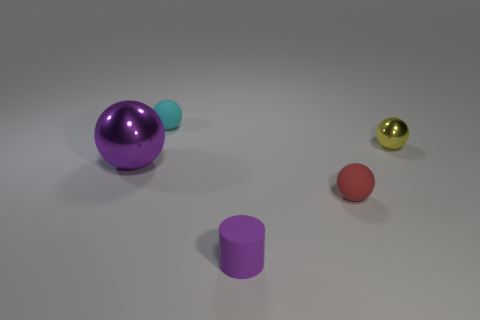Is there anything else that is the same size as the purple metal object?
Keep it short and to the point. No. The red matte object that is the same size as the cyan object is what shape?
Offer a very short reply. Sphere. Is the number of red spheres greater than the number of red metal balls?
Ensure brevity in your answer.  Yes. There is a shiny thing left of the tiny purple rubber thing; is there a matte sphere in front of it?
Provide a succinct answer. Yes. What is the color of the big object that is the same shape as the small yellow object?
Provide a short and direct response. Purple. Is there anything else that has the same shape as the tiny purple rubber object?
Offer a terse response. No. There is a cylinder that is the same material as the small red ball; what color is it?
Offer a very short reply. Purple. There is a small ball that is in front of the shiny ball that is in front of the small metal object; is there a tiny rubber ball behind it?
Keep it short and to the point. Yes. Are there fewer tiny cyan rubber spheres to the left of the big metal thing than matte things to the right of the small yellow sphere?
Keep it short and to the point. No. What number of other small balls have the same material as the purple sphere?
Provide a short and direct response. 1. 